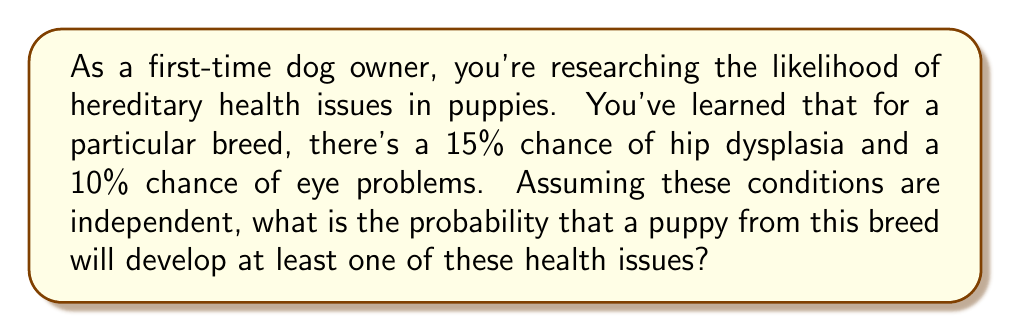Teach me how to tackle this problem. To solve this problem, we'll use the concept of probability of the union of events. Let's break it down step-by-step:

1) Let $H$ be the event that a puppy develops hip dysplasia, and $E$ be the event that a puppy develops eye problems.

2) We're given:
   $P(H) = 15\% = 0.15$
   $P(E) = 10\% = 0.10$

3) We need to find $P(H \cup E)$, which is the probability of at least one of these events occurring.

4) The formula for the probability of the union of two events is:
   $P(H \cup E) = P(H) + P(E) - P(H \cap E)$

5) Since we're told these conditions are independent, we can calculate $P(H \cap E)$ as:
   $P(H \cap E) = P(H) \cdot P(E) = 0.15 \cdot 0.10 = 0.015$

6) Now we can substitute into our formula:
   $P(H \cup E) = 0.15 + 0.10 - 0.015 = 0.235$

7) Convert to a percentage:
   $0.235 \cdot 100\% = 23.5\%$

Therefore, the probability that a puppy from this breed will develop at least one of these health issues is 23.5%.
Answer: 23.5% 